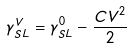<formula> <loc_0><loc_0><loc_500><loc_500>\gamma _ { S L } ^ { V } & = \gamma _ { S L } ^ { 0 } - \frac { C V ^ { 2 } } { 2 }</formula> 